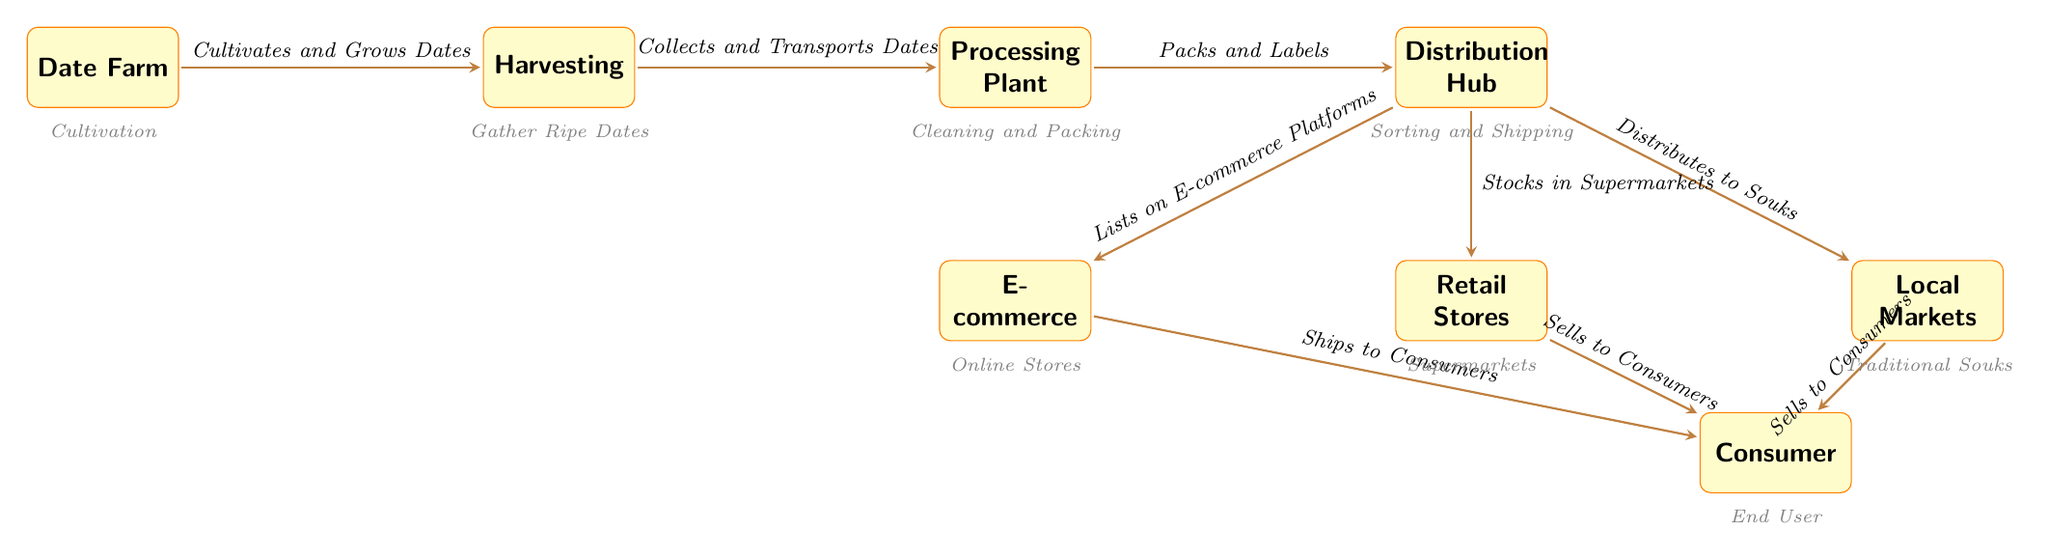What is the first step in the journey of dates? The diagram indicates that the first step is the "Date Farm," where the cultivation of dates takes place.
Answer: Date Farm How many nodes are in the diagram? The diagram features a total of 8 nodes, which include the farm, harvesting, processing, distribution, markets, retail, online, and consumer.
Answer: 8 What process occurs immediately after harvesting? According to the diagram, after harvesting, the next step is "Processing Plant," where the dates are taken for further processing.
Answer: Processing Plant Which node is associated with e-commerce? The diagram highlights "E-commerce" as a node linked to the distribution hub, where dates are listed for online sales.
Answer: E-commerce How are dates sold to consumers from the markets? The diagram illustrates that dates are sold to consumers from the markets through the connection labeled "Sells to Consumers."
Answer: Sells to Consumers What happens at the processing plant? The processing plant is responsible for "Cleaning and Packing," which prepares the dates for distribution.
Answer: Cleaning and Packing What role does the distribution hub play in the supply chain? The distribution hub acts as a central point for sorting and shipping the dates to various outlets, including local markets, retail stores, and online platforms.
Answer: Sorting and Shipping Which node is located directly below the distribution hub? The "Retail Stores" node is positioned directly below the distribution hub, indicating the next step in the supply chain.
Answer: Retail Stores What do local markets do with the dates? Local markets are involved in selling the dates to consumers, as indicated by the connection "Sells to Consumers."
Answer: Sells to Consumers 